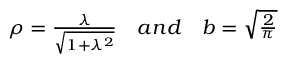<formula> <loc_0><loc_0><loc_500><loc_500>\begin{array} { r } { \rho = \frac { \lambda } { \sqrt { 1 + \lambda ^ { 2 } } } \quad a n d \quad b = \sqrt { \frac { 2 } { \pi } } } \end{array}</formula> 